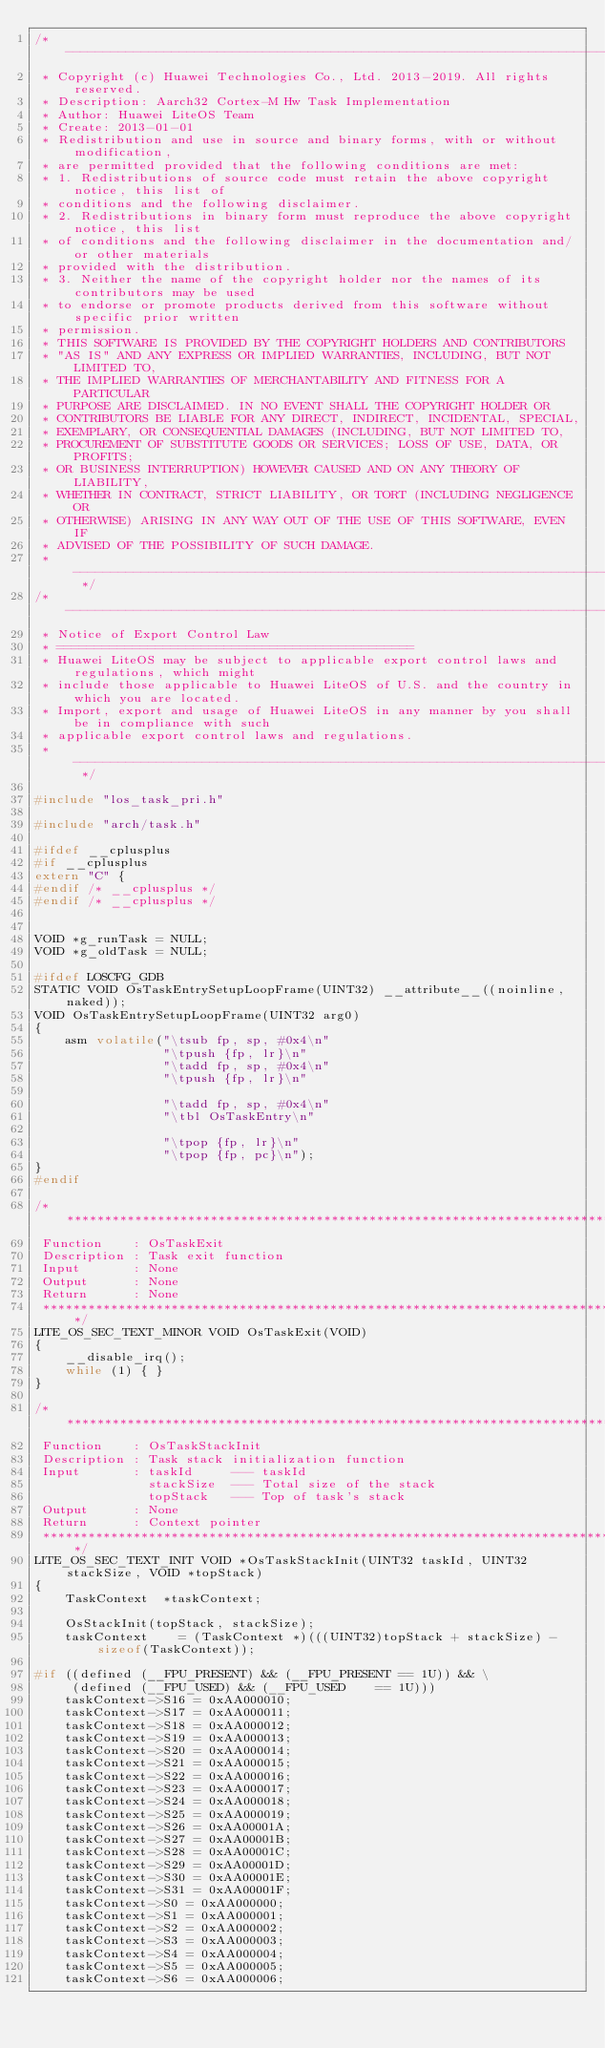Convert code to text. <code><loc_0><loc_0><loc_500><loc_500><_C_>/* ----------------------------------------------------------------------------
 * Copyright (c) Huawei Technologies Co., Ltd. 2013-2019. All rights reserved.
 * Description: Aarch32 Cortex-M Hw Task Implementation
 * Author: Huawei LiteOS Team
 * Create: 2013-01-01
 * Redistribution and use in source and binary forms, with or without modification,
 * are permitted provided that the following conditions are met:
 * 1. Redistributions of source code must retain the above copyright notice, this list of
 * conditions and the following disclaimer.
 * 2. Redistributions in binary form must reproduce the above copyright notice, this list
 * of conditions and the following disclaimer in the documentation and/or other materials
 * provided with the distribution.
 * 3. Neither the name of the copyright holder nor the names of its contributors may be used
 * to endorse or promote products derived from this software without specific prior written
 * permission.
 * THIS SOFTWARE IS PROVIDED BY THE COPYRIGHT HOLDERS AND CONTRIBUTORS
 * "AS IS" AND ANY EXPRESS OR IMPLIED WARRANTIES, INCLUDING, BUT NOT LIMITED TO,
 * THE IMPLIED WARRANTIES OF MERCHANTABILITY AND FITNESS FOR A PARTICULAR
 * PURPOSE ARE DISCLAIMED. IN NO EVENT SHALL THE COPYRIGHT HOLDER OR
 * CONTRIBUTORS BE LIABLE FOR ANY DIRECT, INDIRECT, INCIDENTAL, SPECIAL,
 * EXEMPLARY, OR CONSEQUENTIAL DAMAGES (INCLUDING, BUT NOT LIMITED TO,
 * PROCUREMENT OF SUBSTITUTE GOODS OR SERVICES; LOSS OF USE, DATA, OR PROFITS;
 * OR BUSINESS INTERRUPTION) HOWEVER CAUSED AND ON ANY THEORY OF LIABILITY,
 * WHETHER IN CONTRACT, STRICT LIABILITY, OR TORT (INCLUDING NEGLIGENCE OR
 * OTHERWISE) ARISING IN ANY WAY OUT OF THE USE OF THIS SOFTWARE, EVEN IF
 * ADVISED OF THE POSSIBILITY OF SUCH DAMAGE.
 * --------------------------------------------------------------------------- */
/* ----------------------------------------------------------------------------
 * Notice of Export Control Law
 * ===============================================
 * Huawei LiteOS may be subject to applicable export control laws and regulations, which might
 * include those applicable to Huawei LiteOS of U.S. and the country in which you are located.
 * Import, export and usage of Huawei LiteOS in any manner by you shall be in compliance with such
 * applicable export control laws and regulations.
 * --------------------------------------------------------------------------- */

#include "los_task_pri.h"

#include "arch/task.h"

#ifdef __cplusplus
#if __cplusplus
extern "C" {
#endif /* __cplusplus */
#endif /* __cplusplus */


VOID *g_runTask = NULL;
VOID *g_oldTask = NULL;

#ifdef LOSCFG_GDB
STATIC VOID OsTaskEntrySetupLoopFrame(UINT32) __attribute__((noinline, naked));
VOID OsTaskEntrySetupLoopFrame(UINT32 arg0)
{
    asm volatile("\tsub fp, sp, #0x4\n"
                 "\tpush {fp, lr}\n"
                 "\tadd fp, sp, #0x4\n"
                 "\tpush {fp, lr}\n"

                 "\tadd fp, sp, #0x4\n"
                 "\tbl OsTaskEntry\n"

                 "\tpop {fp, lr}\n"
                 "\tpop {fp, pc}\n");
}
#endif

/*****************************************************************************
 Function    : OsTaskExit
 Description : Task exit function
 Input       : None
 Output      : None
 Return      : None
 *****************************************************************************/
LITE_OS_SEC_TEXT_MINOR VOID OsTaskExit(VOID)
{
    __disable_irq();
    while (1) { }
}

/*****************************************************************************
 Function    : OsTaskStackInit
 Description : Task stack initialization function
 Input       : taskId     --- taskId
               stackSize  --- Total size of the stack
               topStack   --- Top of task's stack
 Output      : None
 Return      : Context pointer
 *****************************************************************************/
LITE_OS_SEC_TEXT_INIT VOID *OsTaskStackInit(UINT32 taskId, UINT32 stackSize, VOID *topStack)
{
    TaskContext  *taskContext;

    OsStackInit(topStack, stackSize);
    taskContext    = (TaskContext *)(((UINT32)topStack + stackSize) - sizeof(TaskContext));

#if ((defined (__FPU_PRESENT) && (__FPU_PRESENT == 1U)) && \
     (defined (__FPU_USED) && (__FPU_USED    == 1U)))
    taskContext->S16 = 0xAA000010;
    taskContext->S17 = 0xAA000011;
    taskContext->S18 = 0xAA000012;
    taskContext->S19 = 0xAA000013;
    taskContext->S20 = 0xAA000014;
    taskContext->S21 = 0xAA000015;
    taskContext->S22 = 0xAA000016;
    taskContext->S23 = 0xAA000017;
    taskContext->S24 = 0xAA000018;
    taskContext->S25 = 0xAA000019;
    taskContext->S26 = 0xAA00001A;
    taskContext->S27 = 0xAA00001B;
    taskContext->S28 = 0xAA00001C;
    taskContext->S29 = 0xAA00001D;
    taskContext->S30 = 0xAA00001E;
    taskContext->S31 = 0xAA00001F;
    taskContext->S0 = 0xAA000000;
    taskContext->S1 = 0xAA000001;
    taskContext->S2 = 0xAA000002;
    taskContext->S3 = 0xAA000003;
    taskContext->S4 = 0xAA000004;
    taskContext->S5 = 0xAA000005;
    taskContext->S6 = 0xAA000006;</code> 